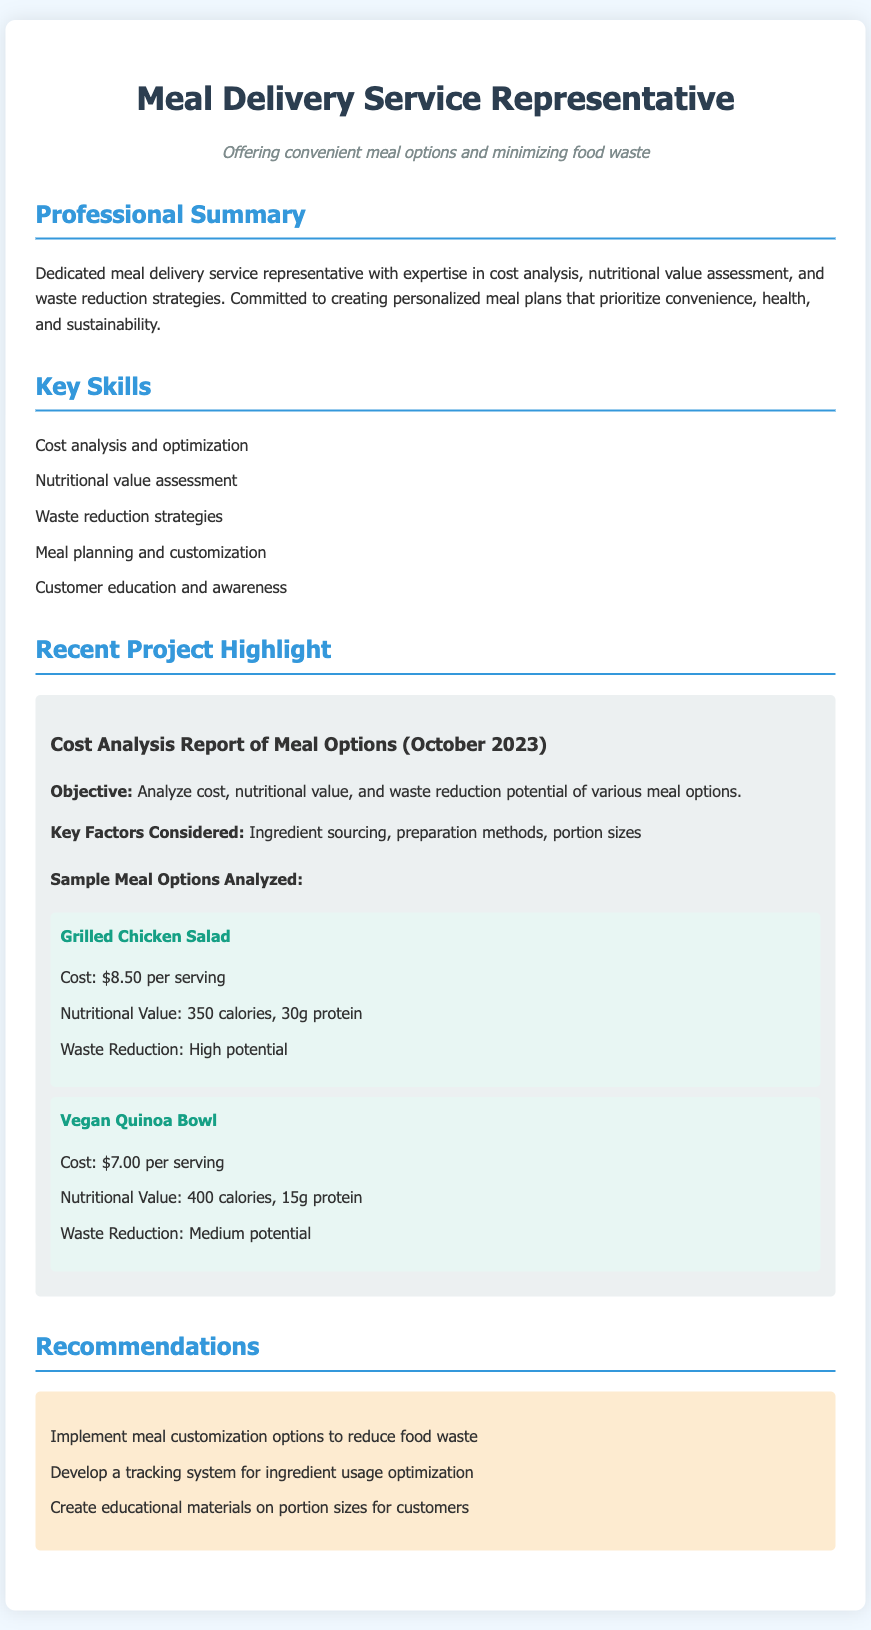what is the cost of the Grilled Chicken Salad? The cost is stated in the meal options section of the document, which lists it as $8.50 per serving.
Answer: $8.50 how many calories does the Vegan Quinoa Bowl contain? The nutritional value of the Vegan Quinoa Bowl is mentioned in the document, and it specifies 400 calories.
Answer: 400 calories what is the protein content of the Grilled Chicken Salad? The document provides specific nutritional details for the Grilled Chicken Salad, stating it contains 30g of protein.
Answer: 30g protein what is the waste reduction potential of the Vegan Quinoa Bowl? The document categorizes the waste reduction potential of the Vegan Quinoa Bowl as medium.
Answer: Medium potential what is the main objective of the Cost Analysis Report? The objective is clearly outlined in the document, describing it as analyzing cost, nutritional value, and waste reduction potential of various meal options.
Answer: Analyze cost, nutritional value, and waste reduction potential which meal option has a high waste reduction potential? The document specifies that the Grilled Chicken Salad has high waste reduction potential.
Answer: Grilled Chicken Salad who is the targeted audience of the recommendations section? The recommendations section aims to educate customers on meal customization and portion sizes, indicating the audience is customers of the meal delivery service.
Answer: Customers what is one of the key skills mentioned for the representative? Among the listed skills in the document, one key skill is cost analysis and optimization.
Answer: Cost analysis and optimization 